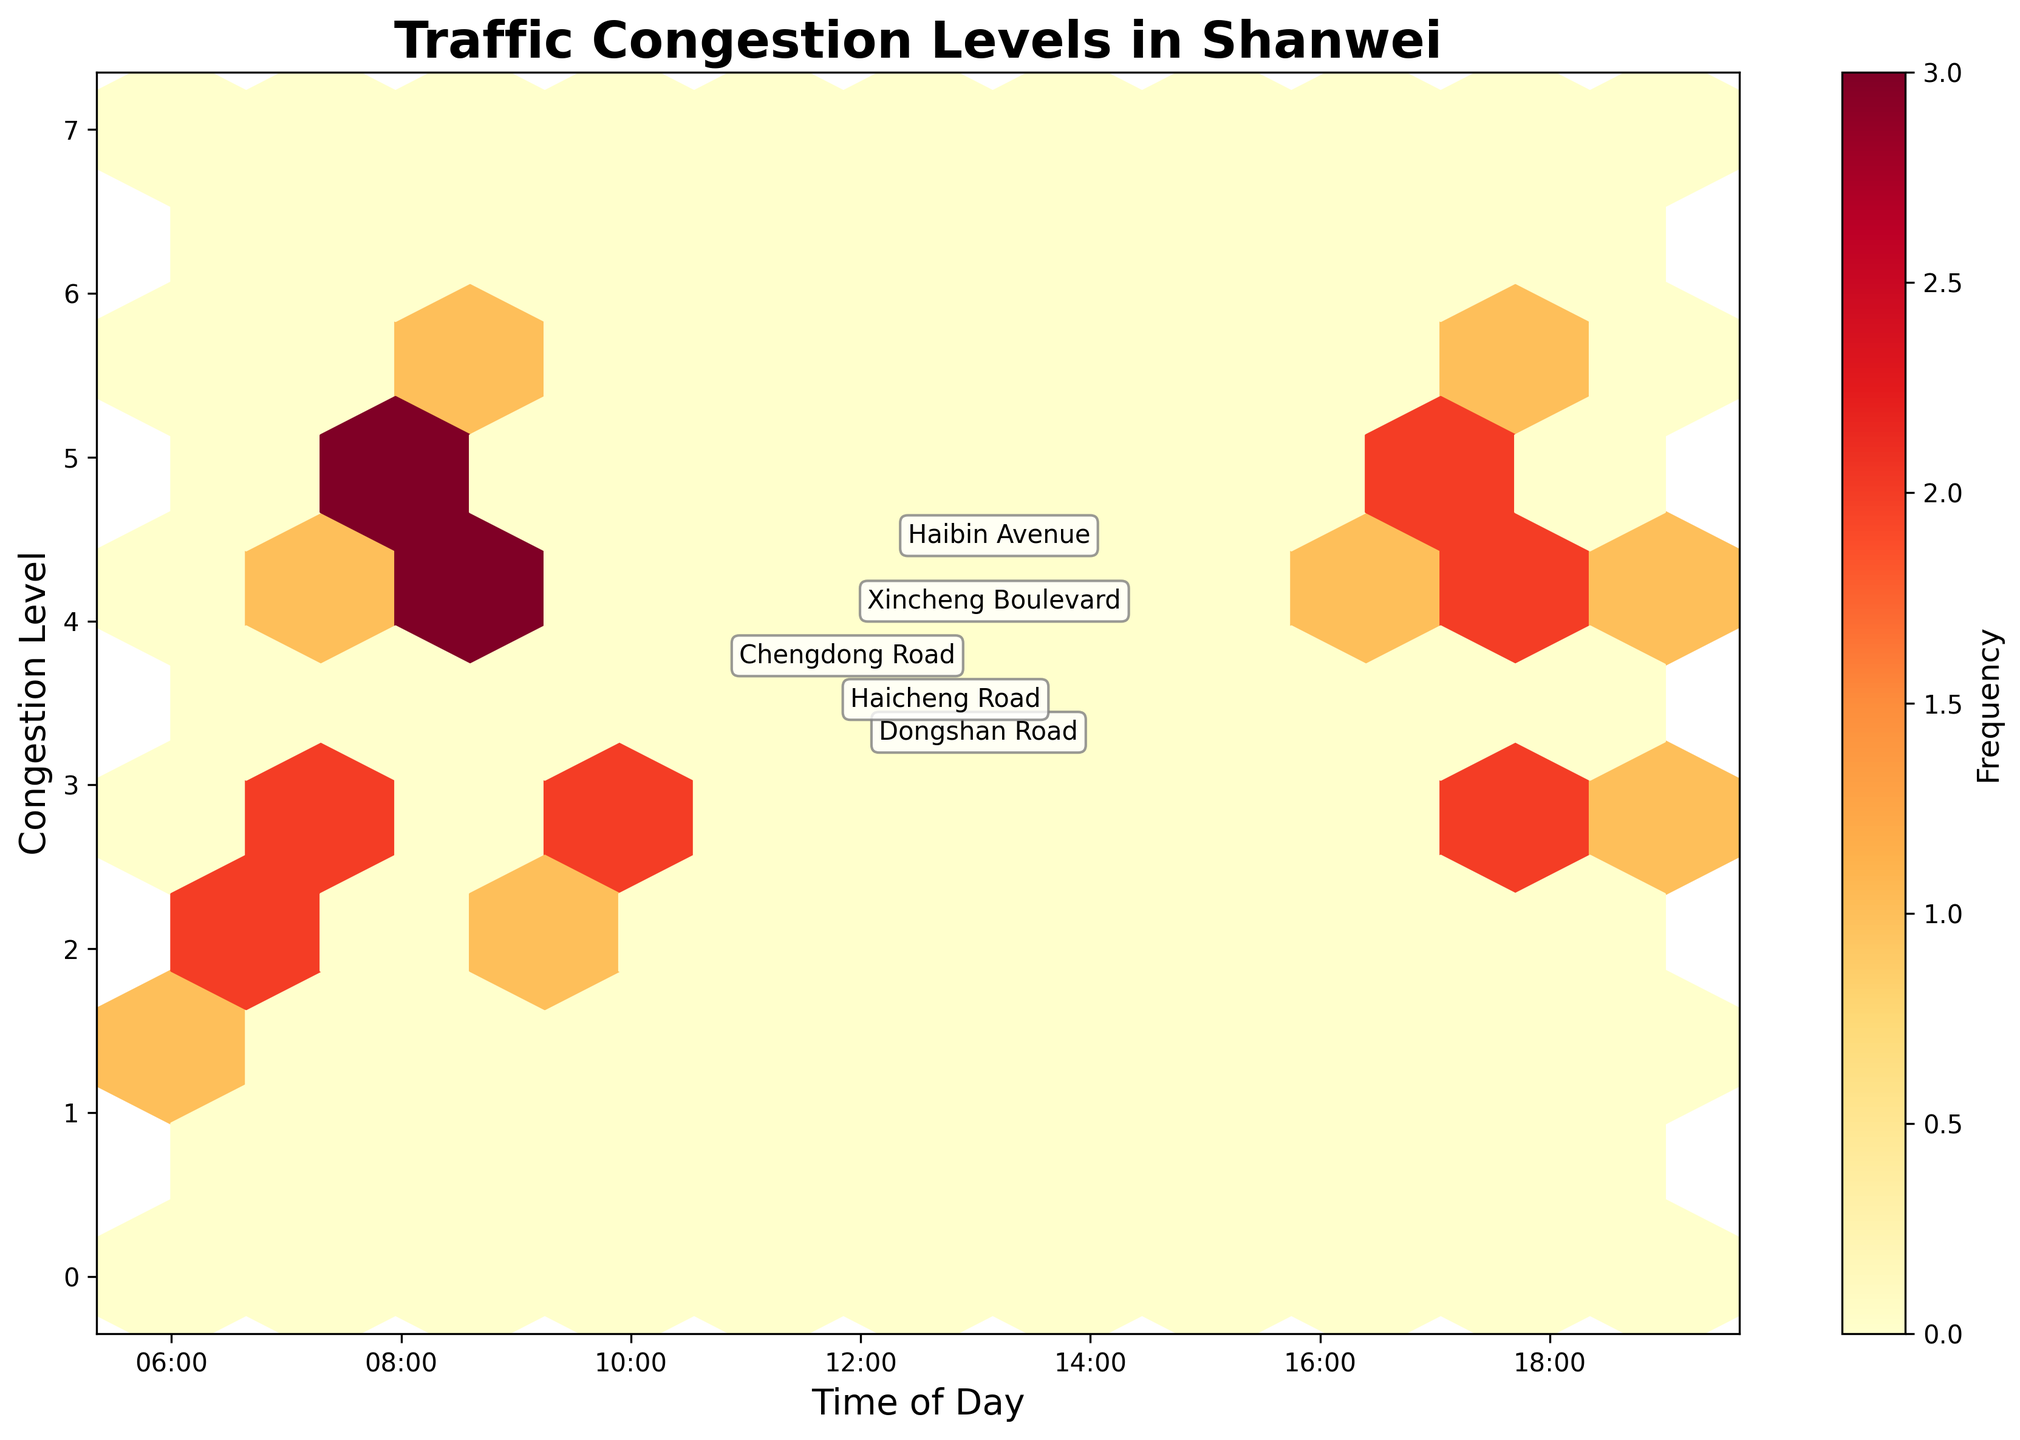What does the title of the plot say? The title is located at the top of the plot and reads "Traffic Congestion Levels in Shanwei," indicating that the plot shows traffic congestion levels throughout the day in Shanwei's main roads.
Answer: "Traffic Congestion Levels in Shanwei" What are the labels on the x and y-axis? The x-axis is labeled "Time of Day," and the y-axis is labeled "Congestion Level." These labels help us understand that the x-axis represents different times of the day, and the y-axis represents the congestion levels.
Answer: "Time of Day", "Congestion Level" What is the range of congestion levels displayed on the y-axis? The y-axis has ticks ranging from 0 to 7, which means that the congestion levels shown in the plot range from 0 to 7.
Answer: 0 to 7 How does the congestion level change over time on Chengdong Road? To understand the congestion level change over time on Chengdong Road, look at the position of marked data points specifically for Chengdong Road. The congestion level increases from 1 at 6:00 to 3 at 7:00 and reaches peak levels of 5 at 8:00, drops to 4 at 9:00, stays at 5 at 17:00, and drops back to 4 at 18:00.
Answer: Peaks at 8:00 and 17:00 Which road has the highest congestion level during the afternoon hours? To determine this, identify the highest congestion levels marked around the afternoon hours, particularly between 12:00 to 19:00. Haibin Avenue hits a congestion level of 6 at 17:30, making it the road with the highest congestion level in the afternoon on the plot.
Answer: Haibin Avenue Do all roads show heavy congestion levels during the early morning hours (6:00 to 9:00)? Evaluate the congestion levels of all roads during early morning hours. Chengdong Road goes from levels 1 to 5, Haibin Avenue from 4 to 6, Dongshan Road from 2 to 4, Xincheng Boulevard from 2 to 5, and Haicheng Road from 2 to 5. Thus, all roads show high congestion levels, especially between 7:00 to 9:00.
Answer: Yes How frequently do congestion levels of 4 or higher occur? By examining the color gradient in the hexbin plot, which represents the frequency of congestion levels, the denser regions associated with higher congestion levels (4, 5, and 6) appear mainly in the morning (7:00-8:30) and late afternoon (17:00-18:30). Many cells are darker at these times, indicating high frequency.
Answer: Very frequently during morning and afternoon rush hours Which road has the least congestion level on average throughout the day? Average congestion levels per road can be approximated by checking the annotated points' positions. Dongshan Road has average congestion levels between 2 and 4, which appears lower compared to other roads reaching level 5 or 6 more frequently.
Answer: Dongshan Road What time of day sees the most prolonged highest congestion levels across all roads? Identify sustained higher congestion levels by examining the plot’s dense regions with high congestion values. Congestion levels consistently rise from 7:00 to 9:00 and again from 17:00 to 18:30, indicating these times experience prolonged highest congestion levels.
Answer: 7:00-9:00 and 17:00-18:30 